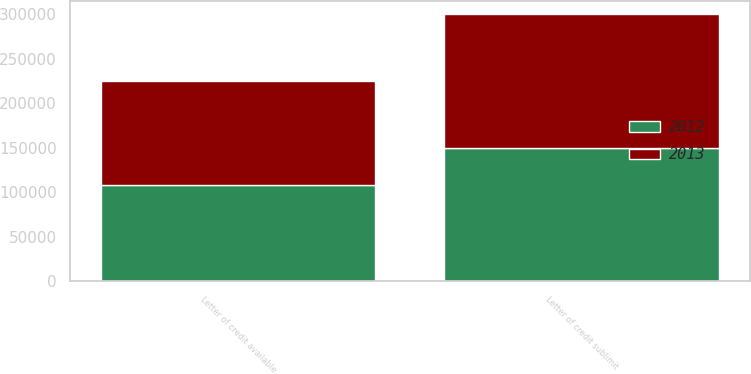Convert chart to OTSL. <chart><loc_0><loc_0><loc_500><loc_500><stacked_bar_chart><ecel><fcel>Letter of credit sublimit<fcel>Letter of credit available<nl><fcel>2012<fcel>150000<fcel>108215<nl><fcel>2013<fcel>150000<fcel>117137<nl></chart> 